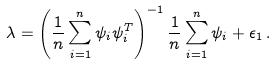Convert formula to latex. <formula><loc_0><loc_0><loc_500><loc_500>\lambda = \left ( \frac { 1 } { n } \sum _ { i = 1 } ^ { n } \psi _ { i } \psi _ { i } ^ { T } \right ) ^ { - 1 } \frac { 1 } { n } \sum _ { i = 1 } ^ { n } \psi _ { i } + \epsilon _ { 1 } \, .</formula> 